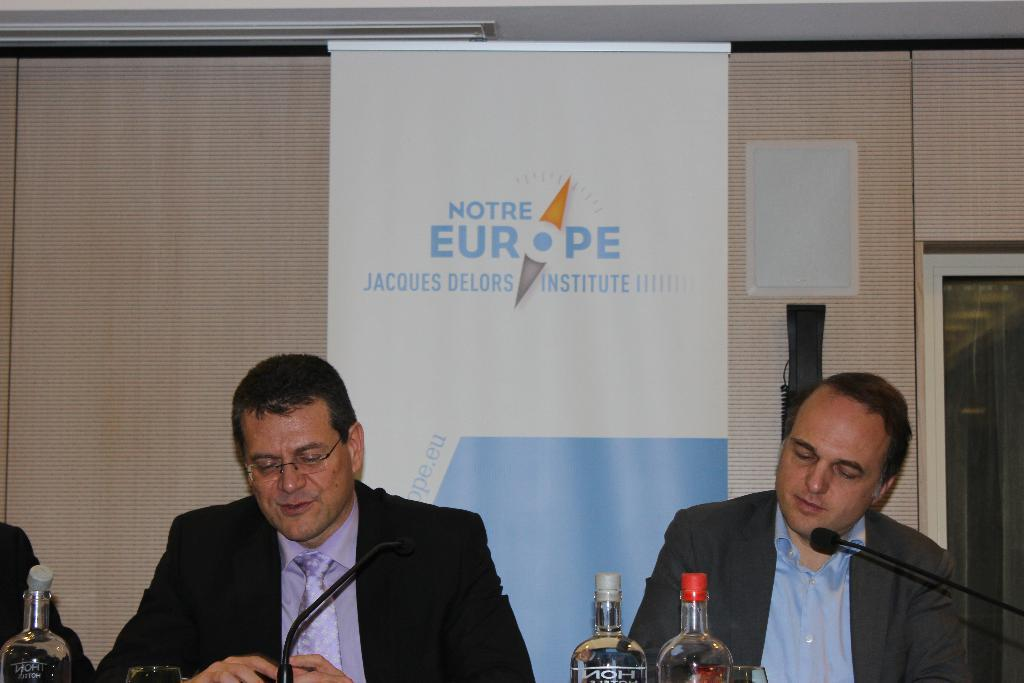<image>
Provide a brief description of the given image. Two men sitting at a table behind a banner for Notre Europe Jacques Delors Institute. 